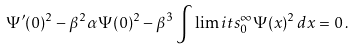Convert formula to latex. <formula><loc_0><loc_0><loc_500><loc_500>\Psi ^ { \prime } ( 0 ) ^ { 2 } - \beta ^ { 2 } \alpha \Psi ( 0 ) ^ { 2 } - \beta ^ { 3 } \int \lim i t s _ { 0 } ^ { \infty } \Psi ( x ) ^ { 2 } \, d x = 0 \, .</formula> 